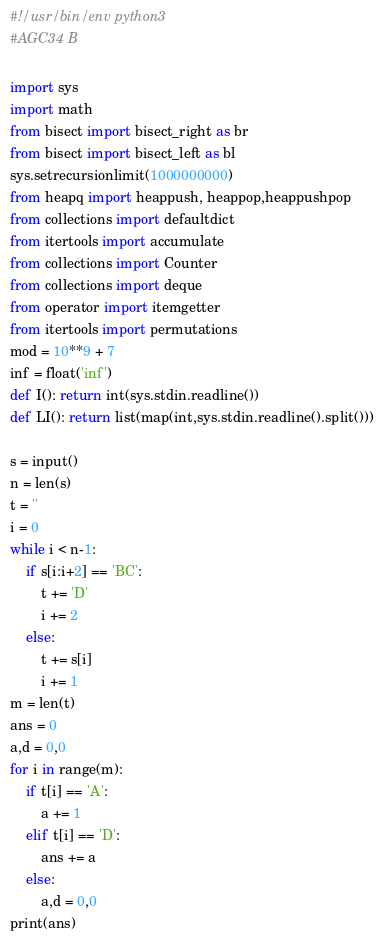Convert code to text. <code><loc_0><loc_0><loc_500><loc_500><_Python_>#!/usr/bin/env python3
#AGC34 B

import sys
import math
from bisect import bisect_right as br
from bisect import bisect_left as bl
sys.setrecursionlimit(1000000000)
from heapq import heappush, heappop,heappushpop
from collections import defaultdict
from itertools import accumulate
from collections import Counter
from collections import deque
from operator import itemgetter
from itertools import permutations
mod = 10**9 + 7
inf = float('inf')
def I(): return int(sys.stdin.readline())
def LI(): return list(map(int,sys.stdin.readline().split()))

s = input()
n = len(s)
t = ''
i = 0
while i < n-1:
    if s[i:i+2] == 'BC':
        t += 'D'
        i += 2
    else:
        t += s[i]
        i += 1
m = len(t)
ans = 0
a,d = 0,0
for i in range(m):
    if t[i] == 'A':
        a += 1
    elif t[i] == 'D':
        ans += a
    else:
        a,d = 0,0
print(ans)
</code> 